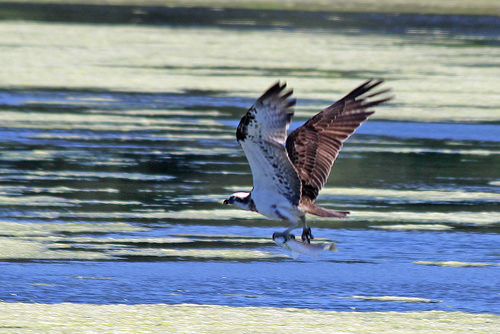<image>
Is there a water to the left of the bird? No. The water is not to the left of the bird. From this viewpoint, they have a different horizontal relationship. Where is the fish in relation to the water? Is it above the water? Yes. The fish is positioned above the water in the vertical space, higher up in the scene. 